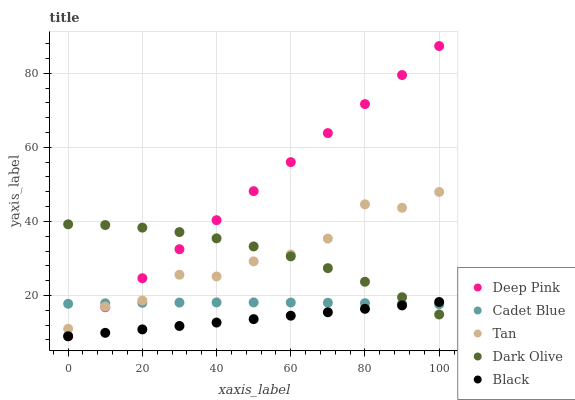Does Black have the minimum area under the curve?
Answer yes or no. Yes. Does Deep Pink have the maximum area under the curve?
Answer yes or no. Yes. Does Tan have the minimum area under the curve?
Answer yes or no. No. Does Tan have the maximum area under the curve?
Answer yes or no. No. Is Black the smoothest?
Answer yes or no. Yes. Is Tan the roughest?
Answer yes or no. Yes. Is Tan the smoothest?
Answer yes or no. No. Is Black the roughest?
Answer yes or no. No. Does Black have the lowest value?
Answer yes or no. Yes. Does Tan have the lowest value?
Answer yes or no. No. Does Deep Pink have the highest value?
Answer yes or no. Yes. Does Black have the highest value?
Answer yes or no. No. Is Black less than Tan?
Answer yes or no. Yes. Is Tan greater than Black?
Answer yes or no. Yes. Does Cadet Blue intersect Dark Olive?
Answer yes or no. Yes. Is Cadet Blue less than Dark Olive?
Answer yes or no. No. Is Cadet Blue greater than Dark Olive?
Answer yes or no. No. Does Black intersect Tan?
Answer yes or no. No. 